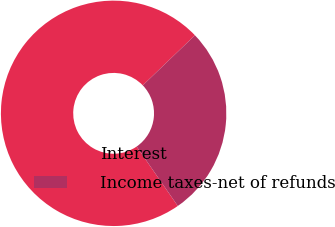<chart> <loc_0><loc_0><loc_500><loc_500><pie_chart><fcel>Interest<fcel>Income taxes-net of refunds<nl><fcel>72.47%<fcel>27.53%<nl></chart> 